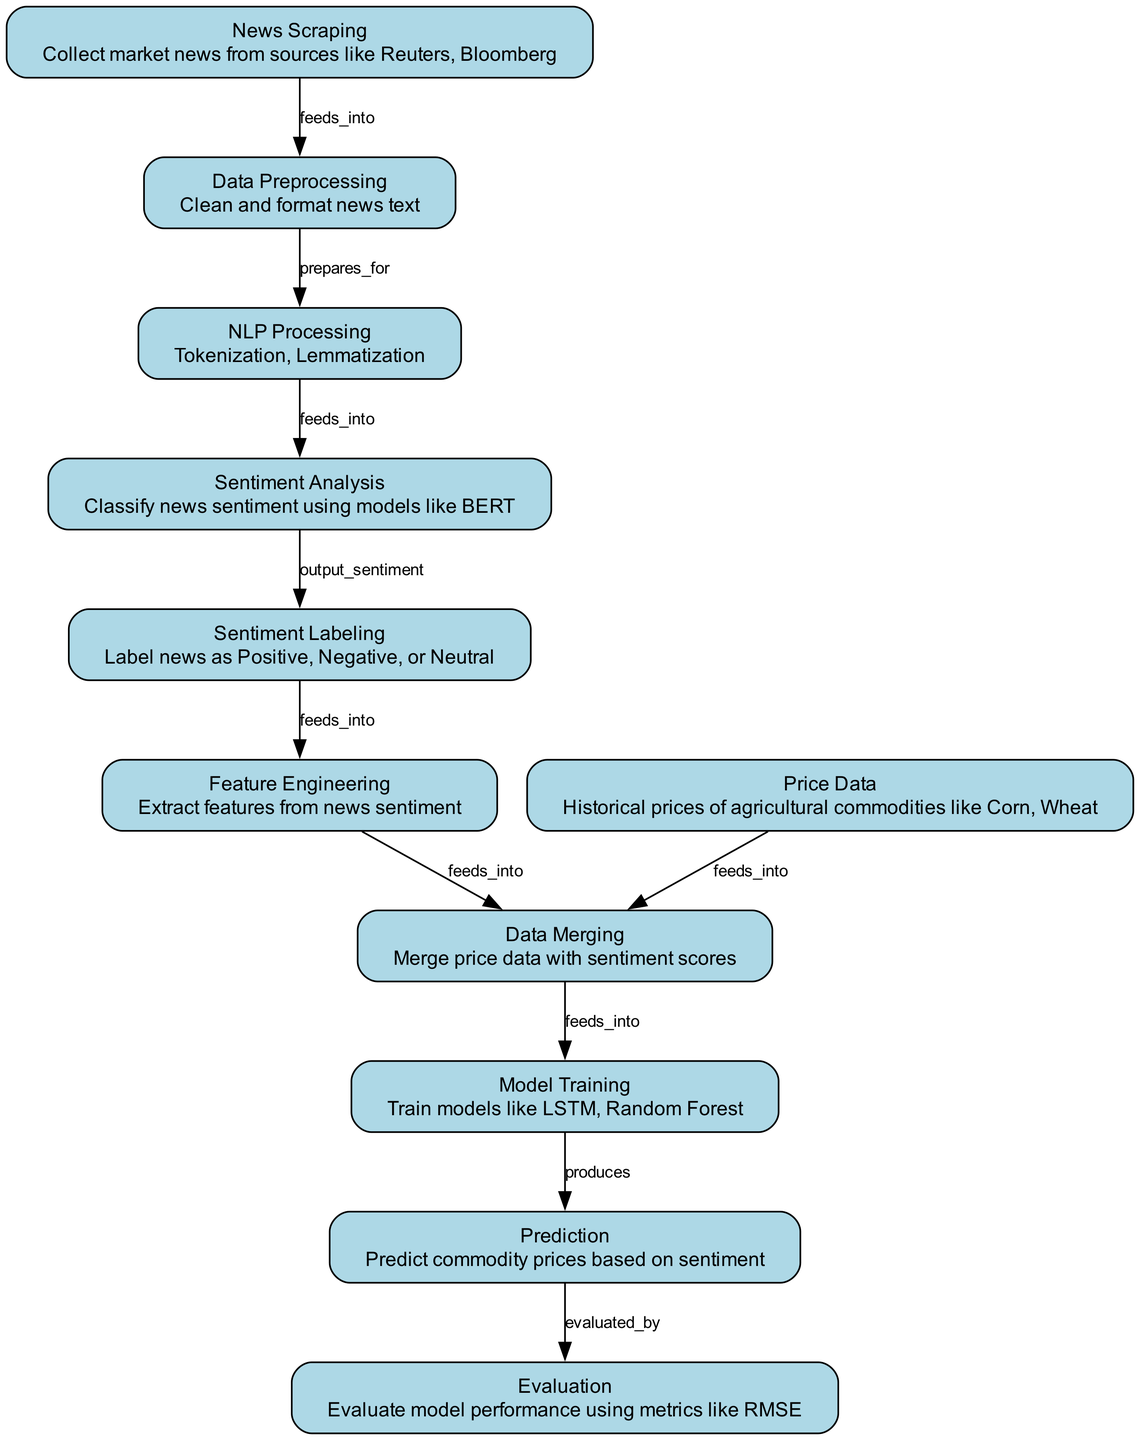What is the first step in the diagram? The first step in the diagram is "News Scraping," which is responsible for collecting market news from various sources.
Answer: News Scraping How many nodes are present in the diagram? The diagram contains ten nodes, each representing a distinct step in the sentiment analysis process.
Answer: Ten What relationship exists between "Sentiment Analysis" and "Sentiment Labeling"? The relationship is that "Sentiment Analysis" feeds into "Sentiment Labeling," indicating that the output from the analysis is used for labeling sentiments.
Answer: feeds into Which model is mentioned for training in the diagram? The diagram mentions "LSTM" and "Random Forest" as models used for training within the machine learning process.
Answer: LSTM, Random Forest What is generated by the "Model Training"? "Model Training" produces predictions, indicating that the training process results in output related to commodity price predictions based on sentiment.
Answer: Prediction What type of data is merged with sentiment scores? The type of data merged with sentiment scores is "Price Data," which consists of historical prices of agricultural commodities.
Answer: Price Data How many edges are there in the diagram? There are nine edges in the diagram, representing the connections and flows between the different nodes.
Answer: Nine What evaluation metric is specified in the diagram? The diagram specifies "RMSE" as the evaluation metric used to assess model performance, indicating that this is a key measure for evaluating predictions.
Answer: RMSE Which process takes the output from "NLP Processing"? The output from "NLP Processing" is taken by "Sentiment Analysis," meaning the processed text is then classified for sentiment.
Answer: Sentiment Analysis 